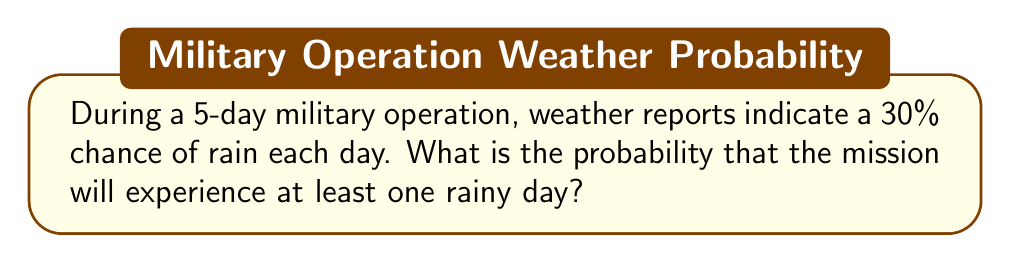Can you solve this math problem? Let's approach this step-by-step:

1) First, we need to calculate the probability of having no rainy days during the 5-day mission.

2) The probability of a dry day is the complement of the probability of a rainy day:
   $P(\text{dry day}) = 1 - P(\text{rainy day}) = 1 - 0.30 = 0.70$ or 70%

3) For the entire mission to be dry, we need all 5 days to be dry. Since the weather each day is independent, we multiply these probabilities:

   $P(\text{all dry}) = 0.70 \times 0.70 \times 0.70 \times 0.70 \times 0.70 = 0.70^5$

4) We can calculate this:
   $0.70^5 \approx 0.16807$ or about 16.807%

5) Now, the probability of having at least one rainy day is the complement of having all dry days:

   $P(\text{at least one rainy day}) = 1 - P(\text{all dry})$
   $= 1 - 0.16807 = 0.83193$

6) Converting to a percentage:
   $0.83193 \times 100\% \approx 83.193\%$

Therefore, the probability of experiencing at least one rainy day during the 5-day mission is approximately 83.193%.
Answer: 83.193% 